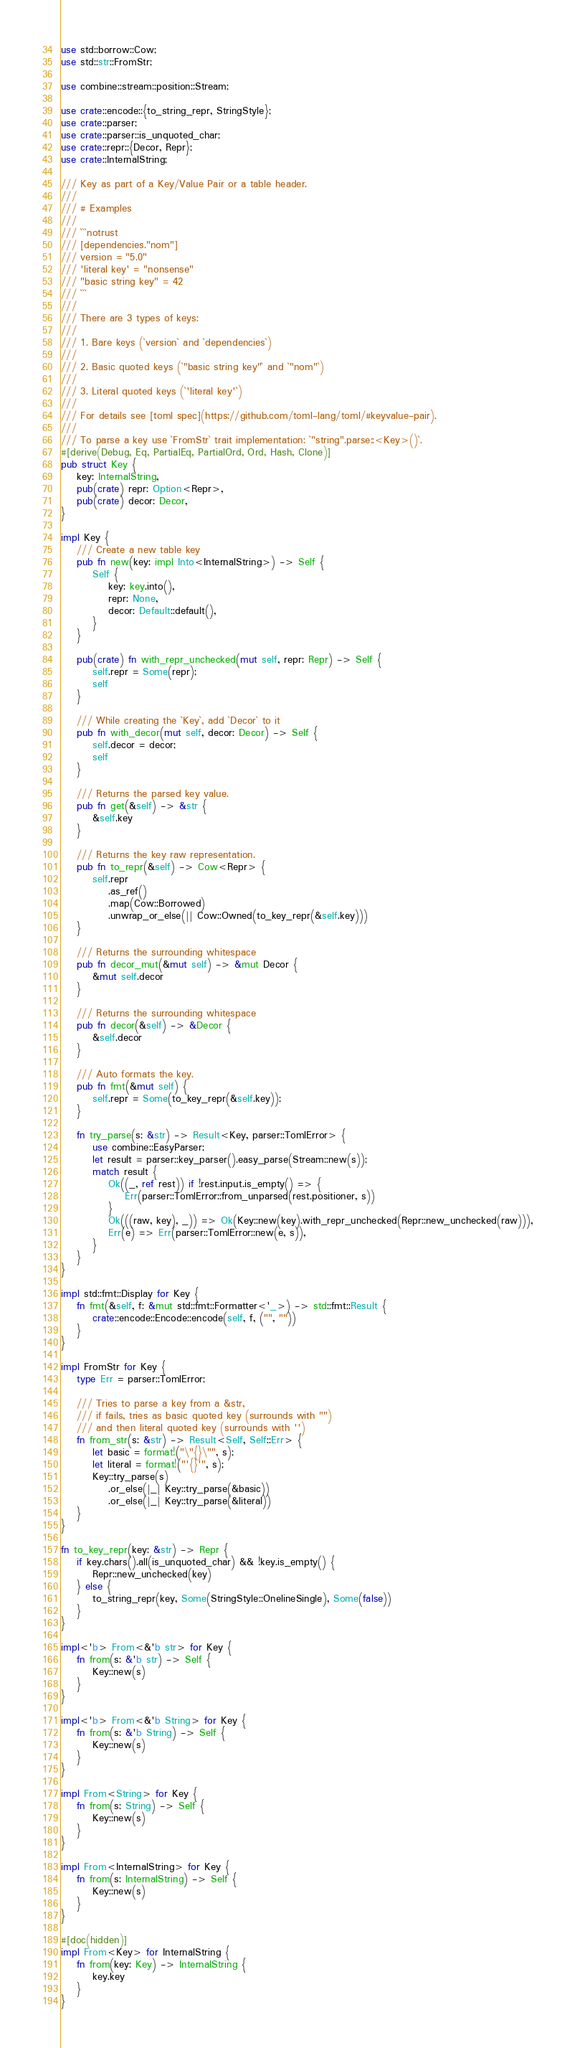Convert code to text. <code><loc_0><loc_0><loc_500><loc_500><_Rust_>use std::borrow::Cow;
use std::str::FromStr;

use combine::stream::position::Stream;

use crate::encode::{to_string_repr, StringStyle};
use crate::parser;
use crate::parser::is_unquoted_char;
use crate::repr::{Decor, Repr};
use crate::InternalString;

/// Key as part of a Key/Value Pair or a table header.
///
/// # Examples
///
/// ```notrust
/// [dependencies."nom"]
/// version = "5.0"
/// 'literal key' = "nonsense"
/// "basic string key" = 42
/// ```
///
/// There are 3 types of keys:
///
/// 1. Bare keys (`version` and `dependencies`)
///
/// 2. Basic quoted keys (`"basic string key"` and `"nom"`)
///
/// 3. Literal quoted keys (`'literal key'`)
///
/// For details see [toml spec](https://github.com/toml-lang/toml/#keyvalue-pair).
///
/// To parse a key use `FromStr` trait implementation: `"string".parse::<Key>()`.
#[derive(Debug, Eq, PartialEq, PartialOrd, Ord, Hash, Clone)]
pub struct Key {
    key: InternalString,
    pub(crate) repr: Option<Repr>,
    pub(crate) decor: Decor,
}

impl Key {
    /// Create a new table key
    pub fn new(key: impl Into<InternalString>) -> Self {
        Self {
            key: key.into(),
            repr: None,
            decor: Default::default(),
        }
    }

    pub(crate) fn with_repr_unchecked(mut self, repr: Repr) -> Self {
        self.repr = Some(repr);
        self
    }

    /// While creating the `Key`, add `Decor` to it
    pub fn with_decor(mut self, decor: Decor) -> Self {
        self.decor = decor;
        self
    }

    /// Returns the parsed key value.
    pub fn get(&self) -> &str {
        &self.key
    }

    /// Returns the key raw representation.
    pub fn to_repr(&self) -> Cow<Repr> {
        self.repr
            .as_ref()
            .map(Cow::Borrowed)
            .unwrap_or_else(|| Cow::Owned(to_key_repr(&self.key)))
    }

    /// Returns the surrounding whitespace
    pub fn decor_mut(&mut self) -> &mut Decor {
        &mut self.decor
    }

    /// Returns the surrounding whitespace
    pub fn decor(&self) -> &Decor {
        &self.decor
    }

    /// Auto formats the key.
    pub fn fmt(&mut self) {
        self.repr = Some(to_key_repr(&self.key));
    }

    fn try_parse(s: &str) -> Result<Key, parser::TomlError> {
        use combine::EasyParser;
        let result = parser::key_parser().easy_parse(Stream::new(s));
        match result {
            Ok((_, ref rest)) if !rest.input.is_empty() => {
                Err(parser::TomlError::from_unparsed(rest.positioner, s))
            }
            Ok(((raw, key), _)) => Ok(Key::new(key).with_repr_unchecked(Repr::new_unchecked(raw))),
            Err(e) => Err(parser::TomlError::new(e, s)),
        }
    }
}

impl std::fmt::Display for Key {
    fn fmt(&self, f: &mut std::fmt::Formatter<'_>) -> std::fmt::Result {
        crate::encode::Encode::encode(self, f, ("", ""))
    }
}

impl FromStr for Key {
    type Err = parser::TomlError;

    /// Tries to parse a key from a &str,
    /// if fails, tries as basic quoted key (surrounds with "")
    /// and then literal quoted key (surrounds with '')
    fn from_str(s: &str) -> Result<Self, Self::Err> {
        let basic = format!("\"{}\"", s);
        let literal = format!("'{}'", s);
        Key::try_parse(s)
            .or_else(|_| Key::try_parse(&basic))
            .or_else(|_| Key::try_parse(&literal))
    }
}

fn to_key_repr(key: &str) -> Repr {
    if key.chars().all(is_unquoted_char) && !key.is_empty() {
        Repr::new_unchecked(key)
    } else {
        to_string_repr(key, Some(StringStyle::OnelineSingle), Some(false))
    }
}

impl<'b> From<&'b str> for Key {
    fn from(s: &'b str) -> Self {
        Key::new(s)
    }
}

impl<'b> From<&'b String> for Key {
    fn from(s: &'b String) -> Self {
        Key::new(s)
    }
}

impl From<String> for Key {
    fn from(s: String) -> Self {
        Key::new(s)
    }
}

impl From<InternalString> for Key {
    fn from(s: InternalString) -> Self {
        Key::new(s)
    }
}

#[doc(hidden)]
impl From<Key> for InternalString {
    fn from(key: Key) -> InternalString {
        key.key
    }
}
</code> 